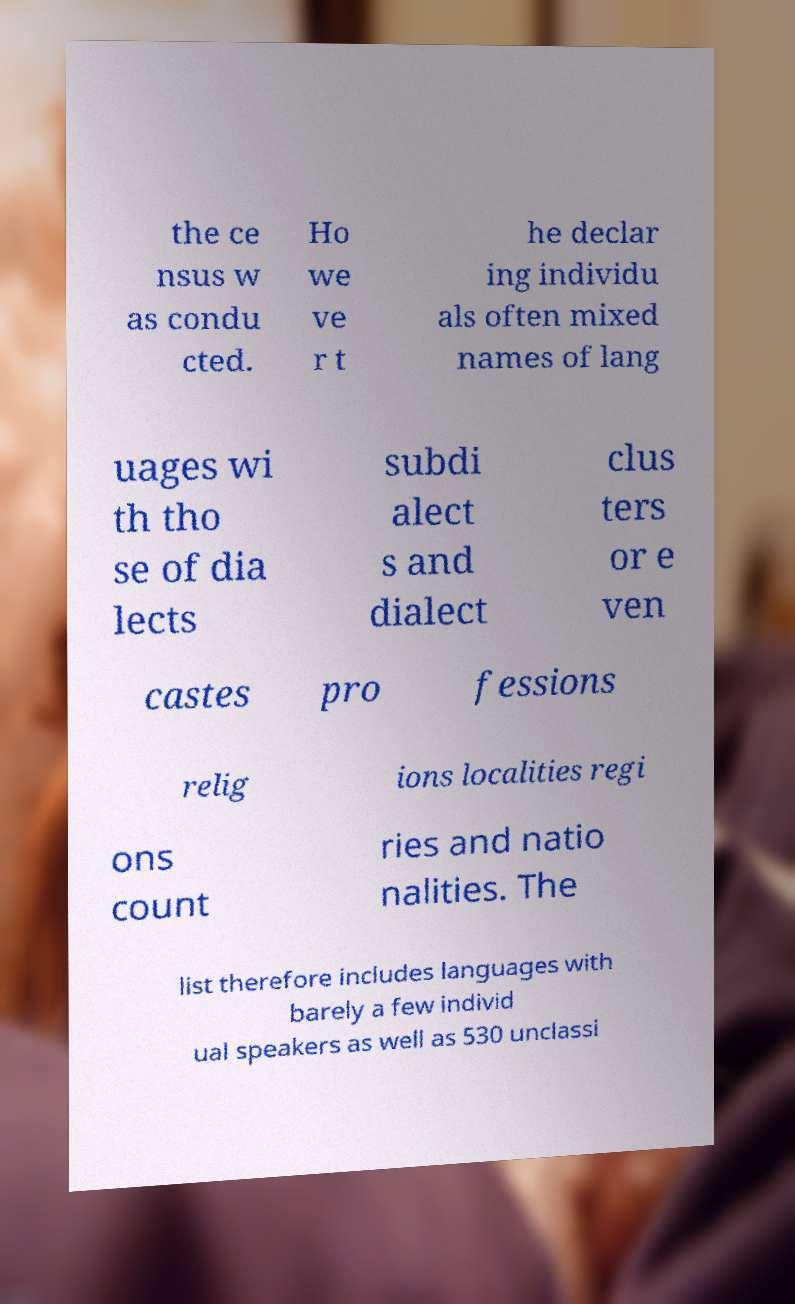Can you read and provide the text displayed in the image?This photo seems to have some interesting text. Can you extract and type it out for me? the ce nsus w as condu cted. Ho we ve r t he declar ing individu als often mixed names of lang uages wi th tho se of dia lects subdi alect s and dialect clus ters or e ven castes pro fessions relig ions localities regi ons count ries and natio nalities. The list therefore includes languages with barely a few individ ual speakers as well as 530 unclassi 